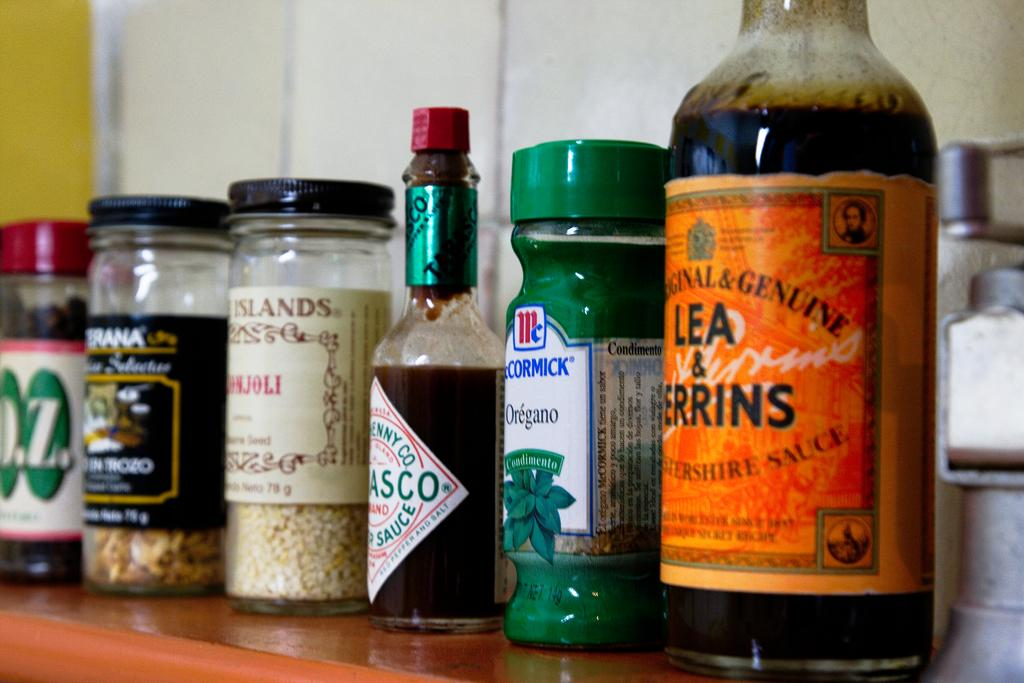<image>
Give a short and clear explanation of the subsequent image. Lea & Perrins Worcestershire sauce sits on a shelf next to several other spices and seasonings. 